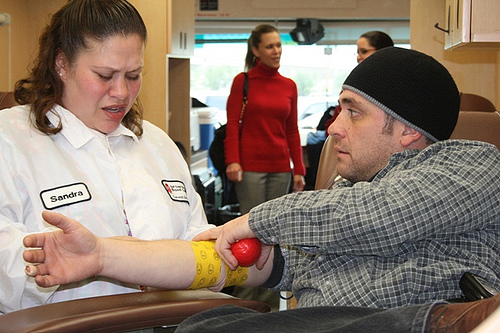<image>
Can you confirm if the man is on the female? No. The man is not positioned on the female. They may be near each other, but the man is not supported by or resting on top of the female. 